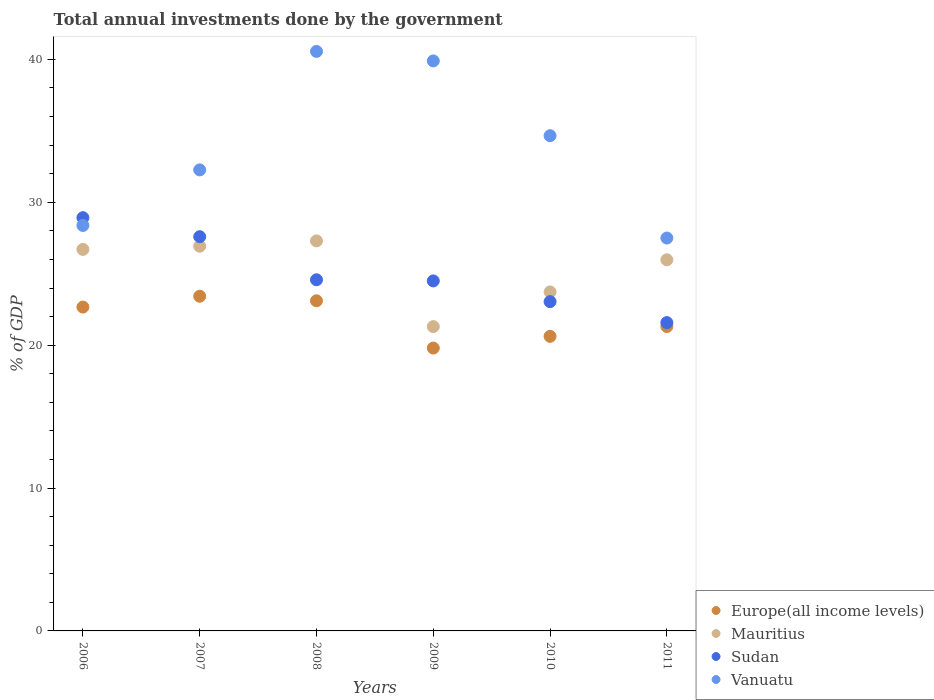What is the total annual investments done by the government in Vanuatu in 2009?
Provide a succinct answer. 39.89. Across all years, what is the maximum total annual investments done by the government in Sudan?
Provide a short and direct response. 28.92. Across all years, what is the minimum total annual investments done by the government in Vanuatu?
Keep it short and to the point. 27.5. In which year was the total annual investments done by the government in Mauritius maximum?
Offer a very short reply. 2008. In which year was the total annual investments done by the government in Vanuatu minimum?
Ensure brevity in your answer.  2011. What is the total total annual investments done by the government in Sudan in the graph?
Keep it short and to the point. 150.21. What is the difference between the total annual investments done by the government in Vanuatu in 2006 and that in 2007?
Give a very brief answer. -3.89. What is the difference between the total annual investments done by the government in Vanuatu in 2011 and the total annual investments done by the government in Mauritius in 2008?
Provide a short and direct response. 0.2. What is the average total annual investments done by the government in Europe(all income levels) per year?
Offer a very short reply. 21.82. In the year 2006, what is the difference between the total annual investments done by the government in Mauritius and total annual investments done by the government in Sudan?
Offer a terse response. -2.22. What is the ratio of the total annual investments done by the government in Europe(all income levels) in 2006 to that in 2010?
Give a very brief answer. 1.1. Is the total annual investments done by the government in Europe(all income levels) in 2007 less than that in 2010?
Your answer should be compact. No. Is the difference between the total annual investments done by the government in Mauritius in 2006 and 2010 greater than the difference between the total annual investments done by the government in Sudan in 2006 and 2010?
Your answer should be compact. No. What is the difference between the highest and the second highest total annual investments done by the government in Sudan?
Your response must be concise. 1.33. What is the difference between the highest and the lowest total annual investments done by the government in Europe(all income levels)?
Make the answer very short. 3.63. Is it the case that in every year, the sum of the total annual investments done by the government in Vanuatu and total annual investments done by the government in Mauritius  is greater than the sum of total annual investments done by the government in Sudan and total annual investments done by the government in Europe(all income levels)?
Make the answer very short. Yes. Is it the case that in every year, the sum of the total annual investments done by the government in Vanuatu and total annual investments done by the government in Mauritius  is greater than the total annual investments done by the government in Europe(all income levels)?
Give a very brief answer. Yes. Is the total annual investments done by the government in Vanuatu strictly less than the total annual investments done by the government in Europe(all income levels) over the years?
Keep it short and to the point. No. How many dotlines are there?
Provide a short and direct response. 4. How many years are there in the graph?
Give a very brief answer. 6. What is the difference between two consecutive major ticks on the Y-axis?
Make the answer very short. 10. Are the values on the major ticks of Y-axis written in scientific E-notation?
Your response must be concise. No. Does the graph contain any zero values?
Keep it short and to the point. No. How many legend labels are there?
Provide a succinct answer. 4. What is the title of the graph?
Your answer should be compact. Total annual investments done by the government. Does "Ecuador" appear as one of the legend labels in the graph?
Your response must be concise. No. What is the label or title of the Y-axis?
Offer a terse response. % of GDP. What is the % of GDP in Europe(all income levels) in 2006?
Provide a succinct answer. 22.67. What is the % of GDP of Mauritius in 2006?
Your answer should be very brief. 26.7. What is the % of GDP in Sudan in 2006?
Ensure brevity in your answer.  28.92. What is the % of GDP in Vanuatu in 2006?
Offer a terse response. 28.38. What is the % of GDP in Europe(all income levels) in 2007?
Your response must be concise. 23.42. What is the % of GDP in Mauritius in 2007?
Give a very brief answer. 26.92. What is the % of GDP of Sudan in 2007?
Keep it short and to the point. 27.59. What is the % of GDP in Vanuatu in 2007?
Provide a short and direct response. 32.27. What is the % of GDP of Europe(all income levels) in 2008?
Your answer should be compact. 23.1. What is the % of GDP of Mauritius in 2008?
Ensure brevity in your answer.  27.3. What is the % of GDP in Sudan in 2008?
Ensure brevity in your answer.  24.58. What is the % of GDP in Vanuatu in 2008?
Give a very brief answer. 40.56. What is the % of GDP of Europe(all income levels) in 2009?
Give a very brief answer. 19.8. What is the % of GDP of Mauritius in 2009?
Give a very brief answer. 21.3. What is the % of GDP of Sudan in 2009?
Your answer should be compact. 24.5. What is the % of GDP in Vanuatu in 2009?
Provide a succinct answer. 39.89. What is the % of GDP in Europe(all income levels) in 2010?
Provide a short and direct response. 20.62. What is the % of GDP in Mauritius in 2010?
Offer a very short reply. 23.73. What is the % of GDP of Sudan in 2010?
Offer a terse response. 23.05. What is the % of GDP in Vanuatu in 2010?
Offer a very short reply. 34.66. What is the % of GDP in Europe(all income levels) in 2011?
Provide a succinct answer. 21.31. What is the % of GDP of Mauritius in 2011?
Offer a terse response. 25.98. What is the % of GDP of Sudan in 2011?
Offer a very short reply. 21.58. What is the % of GDP of Vanuatu in 2011?
Your response must be concise. 27.5. Across all years, what is the maximum % of GDP in Europe(all income levels)?
Provide a succinct answer. 23.42. Across all years, what is the maximum % of GDP of Mauritius?
Provide a short and direct response. 27.3. Across all years, what is the maximum % of GDP in Sudan?
Your response must be concise. 28.92. Across all years, what is the maximum % of GDP in Vanuatu?
Your response must be concise. 40.56. Across all years, what is the minimum % of GDP of Europe(all income levels)?
Offer a very short reply. 19.8. Across all years, what is the minimum % of GDP in Mauritius?
Provide a succinct answer. 21.3. Across all years, what is the minimum % of GDP of Sudan?
Offer a terse response. 21.58. Across all years, what is the minimum % of GDP of Vanuatu?
Offer a terse response. 27.5. What is the total % of GDP in Europe(all income levels) in the graph?
Ensure brevity in your answer.  130.91. What is the total % of GDP of Mauritius in the graph?
Offer a terse response. 151.92. What is the total % of GDP in Sudan in the graph?
Offer a very short reply. 150.21. What is the total % of GDP of Vanuatu in the graph?
Provide a succinct answer. 203.25. What is the difference between the % of GDP of Europe(all income levels) in 2006 and that in 2007?
Provide a succinct answer. -0.76. What is the difference between the % of GDP in Mauritius in 2006 and that in 2007?
Offer a terse response. -0.22. What is the difference between the % of GDP in Sudan in 2006 and that in 2007?
Your answer should be very brief. 1.33. What is the difference between the % of GDP of Vanuatu in 2006 and that in 2007?
Give a very brief answer. -3.89. What is the difference between the % of GDP in Europe(all income levels) in 2006 and that in 2008?
Keep it short and to the point. -0.44. What is the difference between the % of GDP in Mauritius in 2006 and that in 2008?
Your answer should be very brief. -0.6. What is the difference between the % of GDP of Sudan in 2006 and that in 2008?
Offer a very short reply. 4.35. What is the difference between the % of GDP in Vanuatu in 2006 and that in 2008?
Provide a short and direct response. -12.18. What is the difference between the % of GDP in Europe(all income levels) in 2006 and that in 2009?
Make the answer very short. 2.87. What is the difference between the % of GDP of Mauritius in 2006 and that in 2009?
Keep it short and to the point. 5.4. What is the difference between the % of GDP in Sudan in 2006 and that in 2009?
Provide a short and direct response. 4.43. What is the difference between the % of GDP in Vanuatu in 2006 and that in 2009?
Your answer should be very brief. -11.52. What is the difference between the % of GDP of Europe(all income levels) in 2006 and that in 2010?
Your response must be concise. 2.05. What is the difference between the % of GDP of Mauritius in 2006 and that in 2010?
Your answer should be very brief. 2.98. What is the difference between the % of GDP of Sudan in 2006 and that in 2010?
Offer a very short reply. 5.88. What is the difference between the % of GDP in Vanuatu in 2006 and that in 2010?
Your response must be concise. -6.28. What is the difference between the % of GDP of Europe(all income levels) in 2006 and that in 2011?
Keep it short and to the point. 1.36. What is the difference between the % of GDP in Mauritius in 2006 and that in 2011?
Keep it short and to the point. 0.73. What is the difference between the % of GDP in Sudan in 2006 and that in 2011?
Make the answer very short. 7.34. What is the difference between the % of GDP in Vanuatu in 2006 and that in 2011?
Offer a very short reply. 0.88. What is the difference between the % of GDP in Europe(all income levels) in 2007 and that in 2008?
Make the answer very short. 0.32. What is the difference between the % of GDP in Mauritius in 2007 and that in 2008?
Provide a short and direct response. -0.37. What is the difference between the % of GDP in Sudan in 2007 and that in 2008?
Provide a short and direct response. 3.02. What is the difference between the % of GDP in Vanuatu in 2007 and that in 2008?
Make the answer very short. -8.29. What is the difference between the % of GDP of Europe(all income levels) in 2007 and that in 2009?
Keep it short and to the point. 3.63. What is the difference between the % of GDP of Mauritius in 2007 and that in 2009?
Provide a short and direct response. 5.63. What is the difference between the % of GDP in Sudan in 2007 and that in 2009?
Make the answer very short. 3.1. What is the difference between the % of GDP of Vanuatu in 2007 and that in 2009?
Your answer should be very brief. -7.63. What is the difference between the % of GDP of Europe(all income levels) in 2007 and that in 2010?
Offer a terse response. 2.81. What is the difference between the % of GDP in Mauritius in 2007 and that in 2010?
Ensure brevity in your answer.  3.2. What is the difference between the % of GDP in Sudan in 2007 and that in 2010?
Give a very brief answer. 4.55. What is the difference between the % of GDP of Vanuatu in 2007 and that in 2010?
Your answer should be very brief. -2.39. What is the difference between the % of GDP of Europe(all income levels) in 2007 and that in 2011?
Your answer should be compact. 2.12. What is the difference between the % of GDP of Mauritius in 2007 and that in 2011?
Provide a succinct answer. 0.95. What is the difference between the % of GDP in Sudan in 2007 and that in 2011?
Provide a short and direct response. 6.01. What is the difference between the % of GDP in Vanuatu in 2007 and that in 2011?
Offer a terse response. 4.77. What is the difference between the % of GDP in Europe(all income levels) in 2008 and that in 2009?
Your answer should be very brief. 3.31. What is the difference between the % of GDP of Mauritius in 2008 and that in 2009?
Provide a succinct answer. 6. What is the difference between the % of GDP in Sudan in 2008 and that in 2009?
Your answer should be compact. 0.08. What is the difference between the % of GDP of Vanuatu in 2008 and that in 2009?
Offer a very short reply. 0.67. What is the difference between the % of GDP of Europe(all income levels) in 2008 and that in 2010?
Provide a short and direct response. 2.49. What is the difference between the % of GDP in Mauritius in 2008 and that in 2010?
Make the answer very short. 3.57. What is the difference between the % of GDP of Sudan in 2008 and that in 2010?
Your response must be concise. 1.53. What is the difference between the % of GDP of Vanuatu in 2008 and that in 2010?
Provide a succinct answer. 5.9. What is the difference between the % of GDP in Europe(all income levels) in 2008 and that in 2011?
Make the answer very short. 1.8. What is the difference between the % of GDP in Mauritius in 2008 and that in 2011?
Your response must be concise. 1.32. What is the difference between the % of GDP of Sudan in 2008 and that in 2011?
Give a very brief answer. 3. What is the difference between the % of GDP of Vanuatu in 2008 and that in 2011?
Your answer should be compact. 13.06. What is the difference between the % of GDP in Europe(all income levels) in 2009 and that in 2010?
Your response must be concise. -0.82. What is the difference between the % of GDP of Mauritius in 2009 and that in 2010?
Ensure brevity in your answer.  -2.43. What is the difference between the % of GDP of Sudan in 2009 and that in 2010?
Offer a terse response. 1.45. What is the difference between the % of GDP in Vanuatu in 2009 and that in 2010?
Provide a succinct answer. 5.23. What is the difference between the % of GDP of Europe(all income levels) in 2009 and that in 2011?
Offer a terse response. -1.51. What is the difference between the % of GDP of Mauritius in 2009 and that in 2011?
Your response must be concise. -4.68. What is the difference between the % of GDP in Sudan in 2009 and that in 2011?
Offer a very short reply. 2.92. What is the difference between the % of GDP in Vanuatu in 2009 and that in 2011?
Provide a succinct answer. 12.4. What is the difference between the % of GDP of Europe(all income levels) in 2010 and that in 2011?
Ensure brevity in your answer.  -0.69. What is the difference between the % of GDP of Mauritius in 2010 and that in 2011?
Ensure brevity in your answer.  -2.25. What is the difference between the % of GDP in Sudan in 2010 and that in 2011?
Offer a terse response. 1.47. What is the difference between the % of GDP in Vanuatu in 2010 and that in 2011?
Ensure brevity in your answer.  7.16. What is the difference between the % of GDP of Europe(all income levels) in 2006 and the % of GDP of Mauritius in 2007?
Provide a short and direct response. -4.26. What is the difference between the % of GDP of Europe(all income levels) in 2006 and the % of GDP of Sudan in 2007?
Offer a very short reply. -4.93. What is the difference between the % of GDP in Europe(all income levels) in 2006 and the % of GDP in Vanuatu in 2007?
Provide a succinct answer. -9.6. What is the difference between the % of GDP in Mauritius in 2006 and the % of GDP in Sudan in 2007?
Provide a succinct answer. -0.89. What is the difference between the % of GDP in Mauritius in 2006 and the % of GDP in Vanuatu in 2007?
Ensure brevity in your answer.  -5.56. What is the difference between the % of GDP in Sudan in 2006 and the % of GDP in Vanuatu in 2007?
Offer a terse response. -3.34. What is the difference between the % of GDP in Europe(all income levels) in 2006 and the % of GDP in Mauritius in 2008?
Your response must be concise. -4.63. What is the difference between the % of GDP of Europe(all income levels) in 2006 and the % of GDP of Sudan in 2008?
Offer a terse response. -1.91. What is the difference between the % of GDP of Europe(all income levels) in 2006 and the % of GDP of Vanuatu in 2008?
Provide a succinct answer. -17.89. What is the difference between the % of GDP in Mauritius in 2006 and the % of GDP in Sudan in 2008?
Provide a succinct answer. 2.13. What is the difference between the % of GDP of Mauritius in 2006 and the % of GDP of Vanuatu in 2008?
Give a very brief answer. -13.86. What is the difference between the % of GDP in Sudan in 2006 and the % of GDP in Vanuatu in 2008?
Keep it short and to the point. -11.64. What is the difference between the % of GDP of Europe(all income levels) in 2006 and the % of GDP of Mauritius in 2009?
Ensure brevity in your answer.  1.37. What is the difference between the % of GDP of Europe(all income levels) in 2006 and the % of GDP of Sudan in 2009?
Your answer should be very brief. -1.83. What is the difference between the % of GDP of Europe(all income levels) in 2006 and the % of GDP of Vanuatu in 2009?
Ensure brevity in your answer.  -17.23. What is the difference between the % of GDP of Mauritius in 2006 and the % of GDP of Sudan in 2009?
Give a very brief answer. 2.21. What is the difference between the % of GDP in Mauritius in 2006 and the % of GDP in Vanuatu in 2009?
Offer a terse response. -13.19. What is the difference between the % of GDP in Sudan in 2006 and the % of GDP in Vanuatu in 2009?
Make the answer very short. -10.97. What is the difference between the % of GDP in Europe(all income levels) in 2006 and the % of GDP in Mauritius in 2010?
Your response must be concise. -1.06. What is the difference between the % of GDP in Europe(all income levels) in 2006 and the % of GDP in Sudan in 2010?
Keep it short and to the point. -0.38. What is the difference between the % of GDP in Europe(all income levels) in 2006 and the % of GDP in Vanuatu in 2010?
Provide a succinct answer. -11.99. What is the difference between the % of GDP in Mauritius in 2006 and the % of GDP in Sudan in 2010?
Give a very brief answer. 3.66. What is the difference between the % of GDP in Mauritius in 2006 and the % of GDP in Vanuatu in 2010?
Make the answer very short. -7.96. What is the difference between the % of GDP in Sudan in 2006 and the % of GDP in Vanuatu in 2010?
Your response must be concise. -5.74. What is the difference between the % of GDP in Europe(all income levels) in 2006 and the % of GDP in Mauritius in 2011?
Offer a terse response. -3.31. What is the difference between the % of GDP in Europe(all income levels) in 2006 and the % of GDP in Sudan in 2011?
Make the answer very short. 1.09. What is the difference between the % of GDP of Europe(all income levels) in 2006 and the % of GDP of Vanuatu in 2011?
Provide a short and direct response. -4.83. What is the difference between the % of GDP of Mauritius in 2006 and the % of GDP of Sudan in 2011?
Offer a very short reply. 5.12. What is the difference between the % of GDP in Mauritius in 2006 and the % of GDP in Vanuatu in 2011?
Offer a very short reply. -0.8. What is the difference between the % of GDP of Sudan in 2006 and the % of GDP of Vanuatu in 2011?
Provide a short and direct response. 1.43. What is the difference between the % of GDP of Europe(all income levels) in 2007 and the % of GDP of Mauritius in 2008?
Your answer should be very brief. -3.88. What is the difference between the % of GDP of Europe(all income levels) in 2007 and the % of GDP of Sudan in 2008?
Your response must be concise. -1.15. What is the difference between the % of GDP in Europe(all income levels) in 2007 and the % of GDP in Vanuatu in 2008?
Keep it short and to the point. -17.14. What is the difference between the % of GDP in Mauritius in 2007 and the % of GDP in Sudan in 2008?
Make the answer very short. 2.35. What is the difference between the % of GDP of Mauritius in 2007 and the % of GDP of Vanuatu in 2008?
Keep it short and to the point. -13.63. What is the difference between the % of GDP in Sudan in 2007 and the % of GDP in Vanuatu in 2008?
Your answer should be compact. -12.97. What is the difference between the % of GDP of Europe(all income levels) in 2007 and the % of GDP of Mauritius in 2009?
Your answer should be very brief. 2.12. What is the difference between the % of GDP of Europe(all income levels) in 2007 and the % of GDP of Sudan in 2009?
Your answer should be compact. -1.07. What is the difference between the % of GDP of Europe(all income levels) in 2007 and the % of GDP of Vanuatu in 2009?
Give a very brief answer. -16.47. What is the difference between the % of GDP of Mauritius in 2007 and the % of GDP of Sudan in 2009?
Offer a very short reply. 2.43. What is the difference between the % of GDP in Mauritius in 2007 and the % of GDP in Vanuatu in 2009?
Make the answer very short. -12.97. What is the difference between the % of GDP of Sudan in 2007 and the % of GDP of Vanuatu in 2009?
Your answer should be compact. -12.3. What is the difference between the % of GDP of Europe(all income levels) in 2007 and the % of GDP of Mauritius in 2010?
Give a very brief answer. -0.3. What is the difference between the % of GDP of Europe(all income levels) in 2007 and the % of GDP of Sudan in 2010?
Ensure brevity in your answer.  0.38. What is the difference between the % of GDP of Europe(all income levels) in 2007 and the % of GDP of Vanuatu in 2010?
Your response must be concise. -11.24. What is the difference between the % of GDP in Mauritius in 2007 and the % of GDP in Sudan in 2010?
Provide a succinct answer. 3.88. What is the difference between the % of GDP of Mauritius in 2007 and the % of GDP of Vanuatu in 2010?
Keep it short and to the point. -7.74. What is the difference between the % of GDP in Sudan in 2007 and the % of GDP in Vanuatu in 2010?
Make the answer very short. -7.07. What is the difference between the % of GDP of Europe(all income levels) in 2007 and the % of GDP of Mauritius in 2011?
Your answer should be compact. -2.55. What is the difference between the % of GDP in Europe(all income levels) in 2007 and the % of GDP in Sudan in 2011?
Make the answer very short. 1.84. What is the difference between the % of GDP of Europe(all income levels) in 2007 and the % of GDP of Vanuatu in 2011?
Make the answer very short. -4.07. What is the difference between the % of GDP of Mauritius in 2007 and the % of GDP of Sudan in 2011?
Your answer should be compact. 5.35. What is the difference between the % of GDP of Mauritius in 2007 and the % of GDP of Vanuatu in 2011?
Offer a terse response. -0.57. What is the difference between the % of GDP of Sudan in 2007 and the % of GDP of Vanuatu in 2011?
Your answer should be very brief. 0.09. What is the difference between the % of GDP of Europe(all income levels) in 2008 and the % of GDP of Mauritius in 2009?
Your answer should be compact. 1.81. What is the difference between the % of GDP of Europe(all income levels) in 2008 and the % of GDP of Sudan in 2009?
Ensure brevity in your answer.  -1.39. What is the difference between the % of GDP in Europe(all income levels) in 2008 and the % of GDP in Vanuatu in 2009?
Offer a terse response. -16.79. What is the difference between the % of GDP of Mauritius in 2008 and the % of GDP of Sudan in 2009?
Keep it short and to the point. 2.8. What is the difference between the % of GDP of Mauritius in 2008 and the % of GDP of Vanuatu in 2009?
Keep it short and to the point. -12.6. What is the difference between the % of GDP in Sudan in 2008 and the % of GDP in Vanuatu in 2009?
Provide a succinct answer. -15.32. What is the difference between the % of GDP in Europe(all income levels) in 2008 and the % of GDP in Mauritius in 2010?
Provide a short and direct response. -0.62. What is the difference between the % of GDP in Europe(all income levels) in 2008 and the % of GDP in Sudan in 2010?
Give a very brief answer. 0.06. What is the difference between the % of GDP of Europe(all income levels) in 2008 and the % of GDP of Vanuatu in 2010?
Give a very brief answer. -11.55. What is the difference between the % of GDP of Mauritius in 2008 and the % of GDP of Sudan in 2010?
Make the answer very short. 4.25. What is the difference between the % of GDP of Mauritius in 2008 and the % of GDP of Vanuatu in 2010?
Your answer should be very brief. -7.36. What is the difference between the % of GDP of Sudan in 2008 and the % of GDP of Vanuatu in 2010?
Ensure brevity in your answer.  -10.08. What is the difference between the % of GDP in Europe(all income levels) in 2008 and the % of GDP in Mauritius in 2011?
Ensure brevity in your answer.  -2.87. What is the difference between the % of GDP in Europe(all income levels) in 2008 and the % of GDP in Sudan in 2011?
Keep it short and to the point. 1.53. What is the difference between the % of GDP of Europe(all income levels) in 2008 and the % of GDP of Vanuatu in 2011?
Your answer should be compact. -4.39. What is the difference between the % of GDP of Mauritius in 2008 and the % of GDP of Sudan in 2011?
Provide a succinct answer. 5.72. What is the difference between the % of GDP in Mauritius in 2008 and the % of GDP in Vanuatu in 2011?
Offer a terse response. -0.2. What is the difference between the % of GDP in Sudan in 2008 and the % of GDP in Vanuatu in 2011?
Provide a short and direct response. -2.92. What is the difference between the % of GDP in Europe(all income levels) in 2009 and the % of GDP in Mauritius in 2010?
Offer a very short reply. -3.93. What is the difference between the % of GDP of Europe(all income levels) in 2009 and the % of GDP of Sudan in 2010?
Your answer should be compact. -3.25. What is the difference between the % of GDP in Europe(all income levels) in 2009 and the % of GDP in Vanuatu in 2010?
Your response must be concise. -14.86. What is the difference between the % of GDP of Mauritius in 2009 and the % of GDP of Sudan in 2010?
Offer a very short reply. -1.75. What is the difference between the % of GDP in Mauritius in 2009 and the % of GDP in Vanuatu in 2010?
Your response must be concise. -13.36. What is the difference between the % of GDP in Sudan in 2009 and the % of GDP in Vanuatu in 2010?
Offer a very short reply. -10.16. What is the difference between the % of GDP in Europe(all income levels) in 2009 and the % of GDP in Mauritius in 2011?
Give a very brief answer. -6.18. What is the difference between the % of GDP of Europe(all income levels) in 2009 and the % of GDP of Sudan in 2011?
Your answer should be very brief. -1.78. What is the difference between the % of GDP in Europe(all income levels) in 2009 and the % of GDP in Vanuatu in 2011?
Give a very brief answer. -7.7. What is the difference between the % of GDP in Mauritius in 2009 and the % of GDP in Sudan in 2011?
Make the answer very short. -0.28. What is the difference between the % of GDP in Mauritius in 2009 and the % of GDP in Vanuatu in 2011?
Your response must be concise. -6.2. What is the difference between the % of GDP of Sudan in 2009 and the % of GDP of Vanuatu in 2011?
Keep it short and to the point. -3. What is the difference between the % of GDP in Europe(all income levels) in 2010 and the % of GDP in Mauritius in 2011?
Provide a short and direct response. -5.36. What is the difference between the % of GDP in Europe(all income levels) in 2010 and the % of GDP in Sudan in 2011?
Ensure brevity in your answer.  -0.96. What is the difference between the % of GDP of Europe(all income levels) in 2010 and the % of GDP of Vanuatu in 2011?
Offer a terse response. -6.88. What is the difference between the % of GDP of Mauritius in 2010 and the % of GDP of Sudan in 2011?
Your answer should be compact. 2.15. What is the difference between the % of GDP in Mauritius in 2010 and the % of GDP in Vanuatu in 2011?
Offer a very short reply. -3.77. What is the difference between the % of GDP in Sudan in 2010 and the % of GDP in Vanuatu in 2011?
Your answer should be compact. -4.45. What is the average % of GDP in Europe(all income levels) per year?
Provide a short and direct response. 21.82. What is the average % of GDP of Mauritius per year?
Make the answer very short. 25.32. What is the average % of GDP in Sudan per year?
Provide a succinct answer. 25.03. What is the average % of GDP of Vanuatu per year?
Your answer should be compact. 33.88. In the year 2006, what is the difference between the % of GDP in Europe(all income levels) and % of GDP in Mauritius?
Offer a very short reply. -4.04. In the year 2006, what is the difference between the % of GDP of Europe(all income levels) and % of GDP of Sudan?
Ensure brevity in your answer.  -6.26. In the year 2006, what is the difference between the % of GDP in Europe(all income levels) and % of GDP in Vanuatu?
Provide a succinct answer. -5.71. In the year 2006, what is the difference between the % of GDP of Mauritius and % of GDP of Sudan?
Ensure brevity in your answer.  -2.22. In the year 2006, what is the difference between the % of GDP in Mauritius and % of GDP in Vanuatu?
Your response must be concise. -1.68. In the year 2006, what is the difference between the % of GDP of Sudan and % of GDP of Vanuatu?
Give a very brief answer. 0.55. In the year 2007, what is the difference between the % of GDP in Europe(all income levels) and % of GDP in Mauritius?
Your response must be concise. -3.5. In the year 2007, what is the difference between the % of GDP of Europe(all income levels) and % of GDP of Sudan?
Provide a succinct answer. -4.17. In the year 2007, what is the difference between the % of GDP of Europe(all income levels) and % of GDP of Vanuatu?
Give a very brief answer. -8.84. In the year 2007, what is the difference between the % of GDP in Mauritius and % of GDP in Sudan?
Offer a terse response. -0.67. In the year 2007, what is the difference between the % of GDP of Mauritius and % of GDP of Vanuatu?
Provide a short and direct response. -5.34. In the year 2007, what is the difference between the % of GDP in Sudan and % of GDP in Vanuatu?
Give a very brief answer. -4.67. In the year 2008, what is the difference between the % of GDP in Europe(all income levels) and % of GDP in Mauritius?
Your answer should be compact. -4.19. In the year 2008, what is the difference between the % of GDP of Europe(all income levels) and % of GDP of Sudan?
Provide a short and direct response. -1.47. In the year 2008, what is the difference between the % of GDP in Europe(all income levels) and % of GDP in Vanuatu?
Make the answer very short. -17.45. In the year 2008, what is the difference between the % of GDP in Mauritius and % of GDP in Sudan?
Your response must be concise. 2.72. In the year 2008, what is the difference between the % of GDP in Mauritius and % of GDP in Vanuatu?
Provide a succinct answer. -13.26. In the year 2008, what is the difference between the % of GDP in Sudan and % of GDP in Vanuatu?
Make the answer very short. -15.98. In the year 2009, what is the difference between the % of GDP in Europe(all income levels) and % of GDP in Mauritius?
Make the answer very short. -1.5. In the year 2009, what is the difference between the % of GDP of Europe(all income levels) and % of GDP of Sudan?
Make the answer very short. -4.7. In the year 2009, what is the difference between the % of GDP of Europe(all income levels) and % of GDP of Vanuatu?
Your answer should be very brief. -20.1. In the year 2009, what is the difference between the % of GDP of Mauritius and % of GDP of Sudan?
Your answer should be very brief. -3.2. In the year 2009, what is the difference between the % of GDP of Mauritius and % of GDP of Vanuatu?
Offer a terse response. -18.59. In the year 2009, what is the difference between the % of GDP of Sudan and % of GDP of Vanuatu?
Provide a succinct answer. -15.4. In the year 2010, what is the difference between the % of GDP of Europe(all income levels) and % of GDP of Mauritius?
Provide a short and direct response. -3.11. In the year 2010, what is the difference between the % of GDP in Europe(all income levels) and % of GDP in Sudan?
Make the answer very short. -2.43. In the year 2010, what is the difference between the % of GDP of Europe(all income levels) and % of GDP of Vanuatu?
Keep it short and to the point. -14.04. In the year 2010, what is the difference between the % of GDP in Mauritius and % of GDP in Sudan?
Provide a succinct answer. 0.68. In the year 2010, what is the difference between the % of GDP in Mauritius and % of GDP in Vanuatu?
Give a very brief answer. -10.93. In the year 2010, what is the difference between the % of GDP of Sudan and % of GDP of Vanuatu?
Offer a very short reply. -11.61. In the year 2011, what is the difference between the % of GDP of Europe(all income levels) and % of GDP of Mauritius?
Provide a succinct answer. -4.67. In the year 2011, what is the difference between the % of GDP of Europe(all income levels) and % of GDP of Sudan?
Your answer should be very brief. -0.27. In the year 2011, what is the difference between the % of GDP in Europe(all income levels) and % of GDP in Vanuatu?
Provide a succinct answer. -6.19. In the year 2011, what is the difference between the % of GDP in Mauritius and % of GDP in Sudan?
Your answer should be very brief. 4.4. In the year 2011, what is the difference between the % of GDP of Mauritius and % of GDP of Vanuatu?
Offer a terse response. -1.52. In the year 2011, what is the difference between the % of GDP in Sudan and % of GDP in Vanuatu?
Your answer should be very brief. -5.92. What is the ratio of the % of GDP in Europe(all income levels) in 2006 to that in 2007?
Keep it short and to the point. 0.97. What is the ratio of the % of GDP of Sudan in 2006 to that in 2007?
Provide a short and direct response. 1.05. What is the ratio of the % of GDP in Vanuatu in 2006 to that in 2007?
Make the answer very short. 0.88. What is the ratio of the % of GDP in Europe(all income levels) in 2006 to that in 2008?
Offer a very short reply. 0.98. What is the ratio of the % of GDP in Mauritius in 2006 to that in 2008?
Your answer should be very brief. 0.98. What is the ratio of the % of GDP of Sudan in 2006 to that in 2008?
Ensure brevity in your answer.  1.18. What is the ratio of the % of GDP of Vanuatu in 2006 to that in 2008?
Provide a succinct answer. 0.7. What is the ratio of the % of GDP in Europe(all income levels) in 2006 to that in 2009?
Your answer should be compact. 1.14. What is the ratio of the % of GDP of Mauritius in 2006 to that in 2009?
Make the answer very short. 1.25. What is the ratio of the % of GDP in Sudan in 2006 to that in 2009?
Offer a terse response. 1.18. What is the ratio of the % of GDP of Vanuatu in 2006 to that in 2009?
Your response must be concise. 0.71. What is the ratio of the % of GDP in Europe(all income levels) in 2006 to that in 2010?
Offer a very short reply. 1.1. What is the ratio of the % of GDP in Mauritius in 2006 to that in 2010?
Your answer should be very brief. 1.13. What is the ratio of the % of GDP in Sudan in 2006 to that in 2010?
Offer a terse response. 1.25. What is the ratio of the % of GDP in Vanuatu in 2006 to that in 2010?
Provide a succinct answer. 0.82. What is the ratio of the % of GDP of Europe(all income levels) in 2006 to that in 2011?
Give a very brief answer. 1.06. What is the ratio of the % of GDP in Mauritius in 2006 to that in 2011?
Keep it short and to the point. 1.03. What is the ratio of the % of GDP in Sudan in 2006 to that in 2011?
Your answer should be compact. 1.34. What is the ratio of the % of GDP of Vanuatu in 2006 to that in 2011?
Offer a very short reply. 1.03. What is the ratio of the % of GDP of Europe(all income levels) in 2007 to that in 2008?
Your answer should be compact. 1.01. What is the ratio of the % of GDP of Mauritius in 2007 to that in 2008?
Provide a succinct answer. 0.99. What is the ratio of the % of GDP of Sudan in 2007 to that in 2008?
Your answer should be very brief. 1.12. What is the ratio of the % of GDP in Vanuatu in 2007 to that in 2008?
Your response must be concise. 0.8. What is the ratio of the % of GDP of Europe(all income levels) in 2007 to that in 2009?
Your answer should be compact. 1.18. What is the ratio of the % of GDP in Mauritius in 2007 to that in 2009?
Make the answer very short. 1.26. What is the ratio of the % of GDP in Sudan in 2007 to that in 2009?
Provide a short and direct response. 1.13. What is the ratio of the % of GDP in Vanuatu in 2007 to that in 2009?
Provide a succinct answer. 0.81. What is the ratio of the % of GDP of Europe(all income levels) in 2007 to that in 2010?
Offer a very short reply. 1.14. What is the ratio of the % of GDP in Mauritius in 2007 to that in 2010?
Ensure brevity in your answer.  1.13. What is the ratio of the % of GDP in Sudan in 2007 to that in 2010?
Ensure brevity in your answer.  1.2. What is the ratio of the % of GDP of Vanuatu in 2007 to that in 2010?
Keep it short and to the point. 0.93. What is the ratio of the % of GDP of Europe(all income levels) in 2007 to that in 2011?
Offer a very short reply. 1.1. What is the ratio of the % of GDP of Mauritius in 2007 to that in 2011?
Ensure brevity in your answer.  1.04. What is the ratio of the % of GDP in Sudan in 2007 to that in 2011?
Your answer should be compact. 1.28. What is the ratio of the % of GDP of Vanuatu in 2007 to that in 2011?
Your answer should be compact. 1.17. What is the ratio of the % of GDP of Europe(all income levels) in 2008 to that in 2009?
Keep it short and to the point. 1.17. What is the ratio of the % of GDP in Mauritius in 2008 to that in 2009?
Make the answer very short. 1.28. What is the ratio of the % of GDP in Vanuatu in 2008 to that in 2009?
Keep it short and to the point. 1.02. What is the ratio of the % of GDP in Europe(all income levels) in 2008 to that in 2010?
Provide a succinct answer. 1.12. What is the ratio of the % of GDP in Mauritius in 2008 to that in 2010?
Your response must be concise. 1.15. What is the ratio of the % of GDP in Sudan in 2008 to that in 2010?
Keep it short and to the point. 1.07. What is the ratio of the % of GDP of Vanuatu in 2008 to that in 2010?
Ensure brevity in your answer.  1.17. What is the ratio of the % of GDP of Europe(all income levels) in 2008 to that in 2011?
Offer a very short reply. 1.08. What is the ratio of the % of GDP in Mauritius in 2008 to that in 2011?
Offer a terse response. 1.05. What is the ratio of the % of GDP in Sudan in 2008 to that in 2011?
Offer a terse response. 1.14. What is the ratio of the % of GDP in Vanuatu in 2008 to that in 2011?
Offer a very short reply. 1.48. What is the ratio of the % of GDP in Europe(all income levels) in 2009 to that in 2010?
Make the answer very short. 0.96. What is the ratio of the % of GDP of Mauritius in 2009 to that in 2010?
Ensure brevity in your answer.  0.9. What is the ratio of the % of GDP of Sudan in 2009 to that in 2010?
Your response must be concise. 1.06. What is the ratio of the % of GDP in Vanuatu in 2009 to that in 2010?
Keep it short and to the point. 1.15. What is the ratio of the % of GDP of Europe(all income levels) in 2009 to that in 2011?
Make the answer very short. 0.93. What is the ratio of the % of GDP in Mauritius in 2009 to that in 2011?
Provide a succinct answer. 0.82. What is the ratio of the % of GDP in Sudan in 2009 to that in 2011?
Make the answer very short. 1.14. What is the ratio of the % of GDP of Vanuatu in 2009 to that in 2011?
Your answer should be very brief. 1.45. What is the ratio of the % of GDP of Europe(all income levels) in 2010 to that in 2011?
Your answer should be very brief. 0.97. What is the ratio of the % of GDP in Mauritius in 2010 to that in 2011?
Provide a succinct answer. 0.91. What is the ratio of the % of GDP of Sudan in 2010 to that in 2011?
Your response must be concise. 1.07. What is the ratio of the % of GDP of Vanuatu in 2010 to that in 2011?
Your response must be concise. 1.26. What is the difference between the highest and the second highest % of GDP of Europe(all income levels)?
Ensure brevity in your answer.  0.32. What is the difference between the highest and the second highest % of GDP of Mauritius?
Provide a succinct answer. 0.37. What is the difference between the highest and the second highest % of GDP of Sudan?
Your response must be concise. 1.33. What is the difference between the highest and the second highest % of GDP of Vanuatu?
Provide a short and direct response. 0.67. What is the difference between the highest and the lowest % of GDP in Europe(all income levels)?
Offer a very short reply. 3.63. What is the difference between the highest and the lowest % of GDP in Mauritius?
Offer a very short reply. 6. What is the difference between the highest and the lowest % of GDP of Sudan?
Provide a short and direct response. 7.34. What is the difference between the highest and the lowest % of GDP of Vanuatu?
Your answer should be compact. 13.06. 